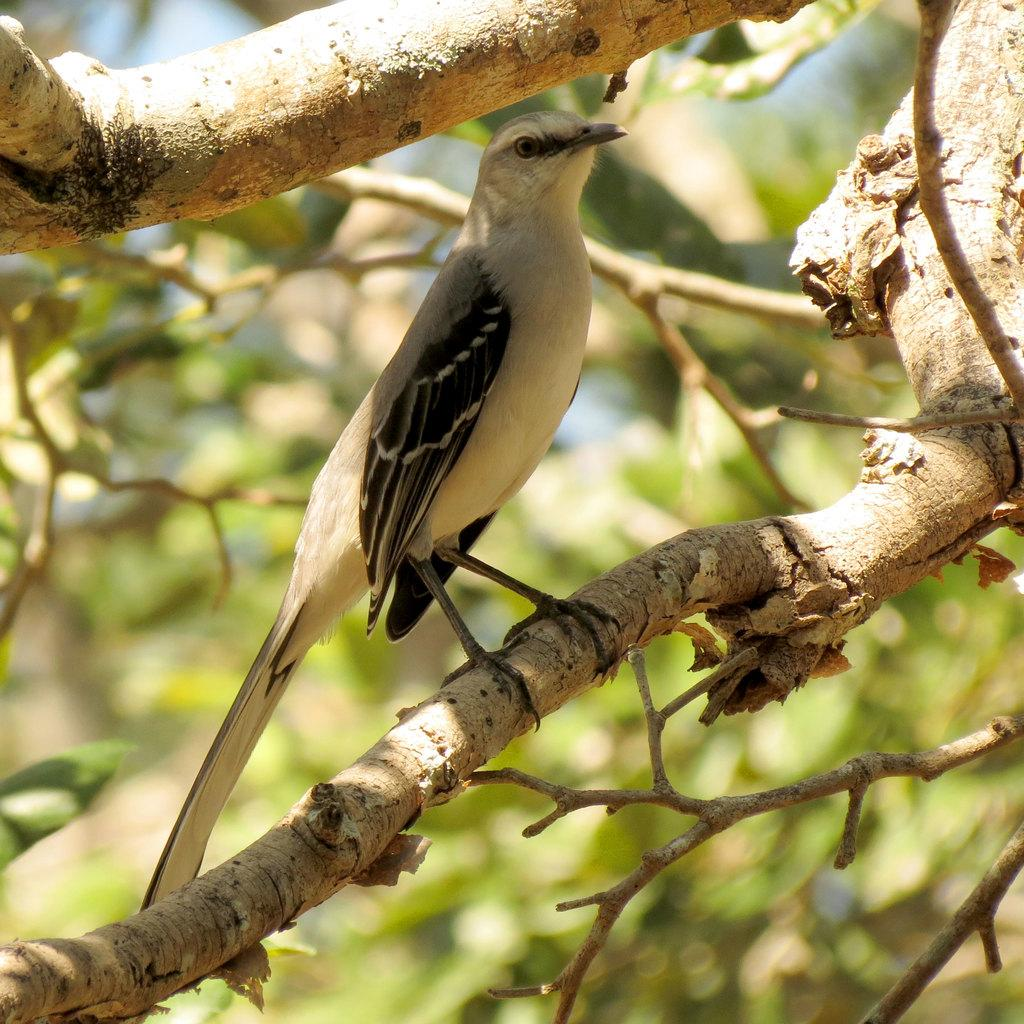What type of animal can be seen in the image? There is a bird in the image. Where is the bird located? The bird is standing on a tree branch. Can you describe the background of the image? The background of the image appears blurry. What type of badge is the bird wearing in the image? There is no badge present on the bird in the image. What station does the bird belong to in the image? The image does not depict a bird belonging to any station or organization. 